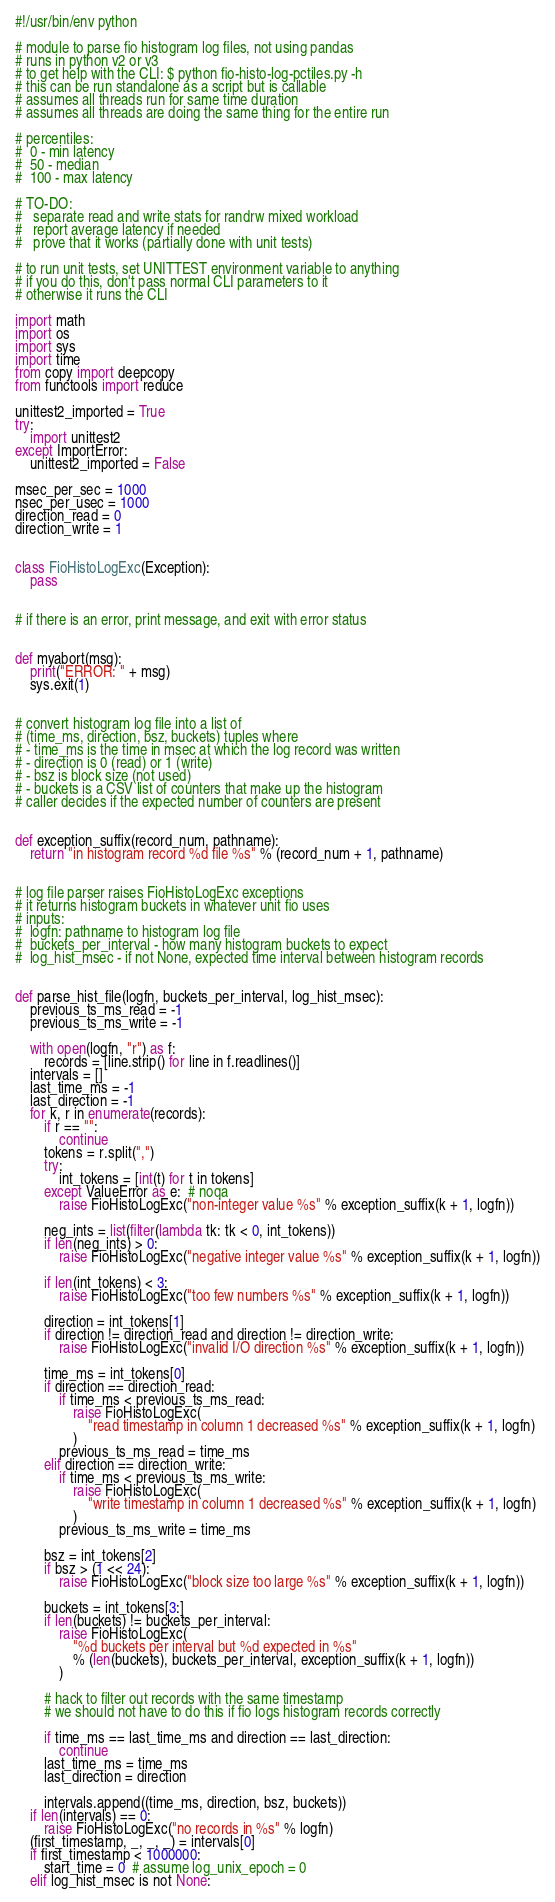Convert code to text. <code><loc_0><loc_0><loc_500><loc_500><_Python_>#!/usr/bin/env python

# module to parse fio histogram log files, not using pandas
# runs in python v2 or v3
# to get help with the CLI: $ python fio-histo-log-pctiles.py -h
# this can be run standalone as a script but is callable
# assumes all threads run for same time duration
# assumes all threads are doing the same thing for the entire run

# percentiles:
#  0 - min latency
#  50 - median
#  100 - max latency

# TO-DO:
#   separate read and write stats for randrw mixed workload
#   report average latency if needed
#   prove that it works (partially done with unit tests)

# to run unit tests, set UNITTEST environment variable to anything
# if you do this, don't pass normal CLI parameters to it
# otherwise it runs the CLI

import math
import os
import sys
import time
from copy import deepcopy
from functools import reduce

unittest2_imported = True
try:
    import unittest2
except ImportError:
    unittest2_imported = False

msec_per_sec = 1000
nsec_per_usec = 1000
direction_read = 0
direction_write = 1


class FioHistoLogExc(Exception):
    pass


# if there is an error, print message, and exit with error status


def myabort(msg):
    print("ERROR: " + msg)
    sys.exit(1)


# convert histogram log file into a list of
# (time_ms, direction, bsz, buckets) tuples where
# - time_ms is the time in msec at which the log record was written
# - direction is 0 (read) or 1 (write)
# - bsz is block size (not used)
# - buckets is a CSV list of counters that make up the histogram
# caller decides if the expected number of counters are present


def exception_suffix(record_num, pathname):
    return "in histogram record %d file %s" % (record_num + 1, pathname)


# log file parser raises FioHistoLogExc exceptions
# it returns histogram buckets in whatever unit fio uses
# inputs:
#  logfn: pathname to histogram log file
#  buckets_per_interval - how many histogram buckets to expect
#  log_hist_msec - if not None, expected time interval between histogram records


def parse_hist_file(logfn, buckets_per_interval, log_hist_msec):
    previous_ts_ms_read = -1
    previous_ts_ms_write = -1

    with open(logfn, "r") as f:
        records = [line.strip() for line in f.readlines()]
    intervals = []
    last_time_ms = -1
    last_direction = -1
    for k, r in enumerate(records):
        if r == "":
            continue
        tokens = r.split(",")
        try:
            int_tokens = [int(t) for t in tokens]
        except ValueError as e:  # noqa
            raise FioHistoLogExc("non-integer value %s" % exception_suffix(k + 1, logfn))

        neg_ints = list(filter(lambda tk: tk < 0, int_tokens))
        if len(neg_ints) > 0:
            raise FioHistoLogExc("negative integer value %s" % exception_suffix(k + 1, logfn))

        if len(int_tokens) < 3:
            raise FioHistoLogExc("too few numbers %s" % exception_suffix(k + 1, logfn))

        direction = int_tokens[1]
        if direction != direction_read and direction != direction_write:
            raise FioHistoLogExc("invalid I/O direction %s" % exception_suffix(k + 1, logfn))

        time_ms = int_tokens[0]
        if direction == direction_read:
            if time_ms < previous_ts_ms_read:
                raise FioHistoLogExc(
                    "read timestamp in column 1 decreased %s" % exception_suffix(k + 1, logfn)
                )
            previous_ts_ms_read = time_ms
        elif direction == direction_write:
            if time_ms < previous_ts_ms_write:
                raise FioHistoLogExc(
                    "write timestamp in column 1 decreased %s" % exception_suffix(k + 1, logfn)
                )
            previous_ts_ms_write = time_ms

        bsz = int_tokens[2]
        if bsz > (1 << 24):
            raise FioHistoLogExc("block size too large %s" % exception_suffix(k + 1, logfn))

        buckets = int_tokens[3:]
        if len(buckets) != buckets_per_interval:
            raise FioHistoLogExc(
                "%d buckets per interval but %d expected in %s"
                % (len(buckets), buckets_per_interval, exception_suffix(k + 1, logfn))
            )

        # hack to filter out records with the same timestamp
        # we should not have to do this if fio logs histogram records correctly

        if time_ms == last_time_ms and direction == last_direction:
            continue
        last_time_ms = time_ms
        last_direction = direction

        intervals.append((time_ms, direction, bsz, buckets))
    if len(intervals) == 0:
        raise FioHistoLogExc("no records in %s" % logfn)
    (first_timestamp, _, _, _) = intervals[0]
    if first_timestamp < 1000000:
        start_time = 0  # assume log_unix_epoch = 0
    elif log_hist_msec is not None:</code> 